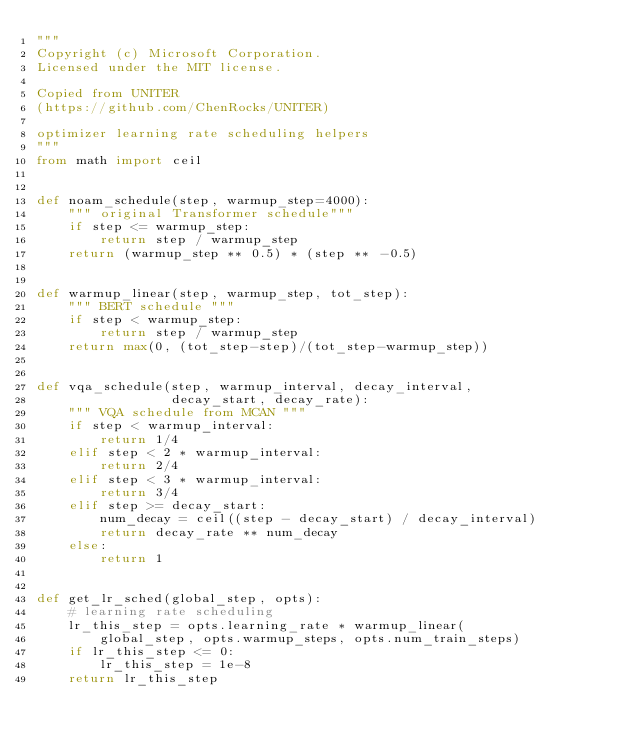<code> <loc_0><loc_0><loc_500><loc_500><_Python_>"""
Copyright (c) Microsoft Corporation.
Licensed under the MIT license.

Copied from UNITER
(https://github.com/ChenRocks/UNITER)

optimizer learning rate scheduling helpers
"""
from math import ceil


def noam_schedule(step, warmup_step=4000):
    """ original Transformer schedule"""
    if step <= warmup_step:
        return step / warmup_step
    return (warmup_step ** 0.5) * (step ** -0.5)


def warmup_linear(step, warmup_step, tot_step):
    """ BERT schedule """
    if step < warmup_step:
        return step / warmup_step
    return max(0, (tot_step-step)/(tot_step-warmup_step))


def vqa_schedule(step, warmup_interval, decay_interval,
                 decay_start, decay_rate):
    """ VQA schedule from MCAN """
    if step < warmup_interval:
        return 1/4
    elif step < 2 * warmup_interval:
        return 2/4
    elif step < 3 * warmup_interval:
        return 3/4
    elif step >= decay_start:
        num_decay = ceil((step - decay_start) / decay_interval)
        return decay_rate ** num_decay
    else:
        return 1


def get_lr_sched(global_step, opts):
    # learning rate scheduling
    lr_this_step = opts.learning_rate * warmup_linear(
        global_step, opts.warmup_steps, opts.num_train_steps)
    if lr_this_step <= 0:
        lr_this_step = 1e-8
    return lr_this_step</code> 